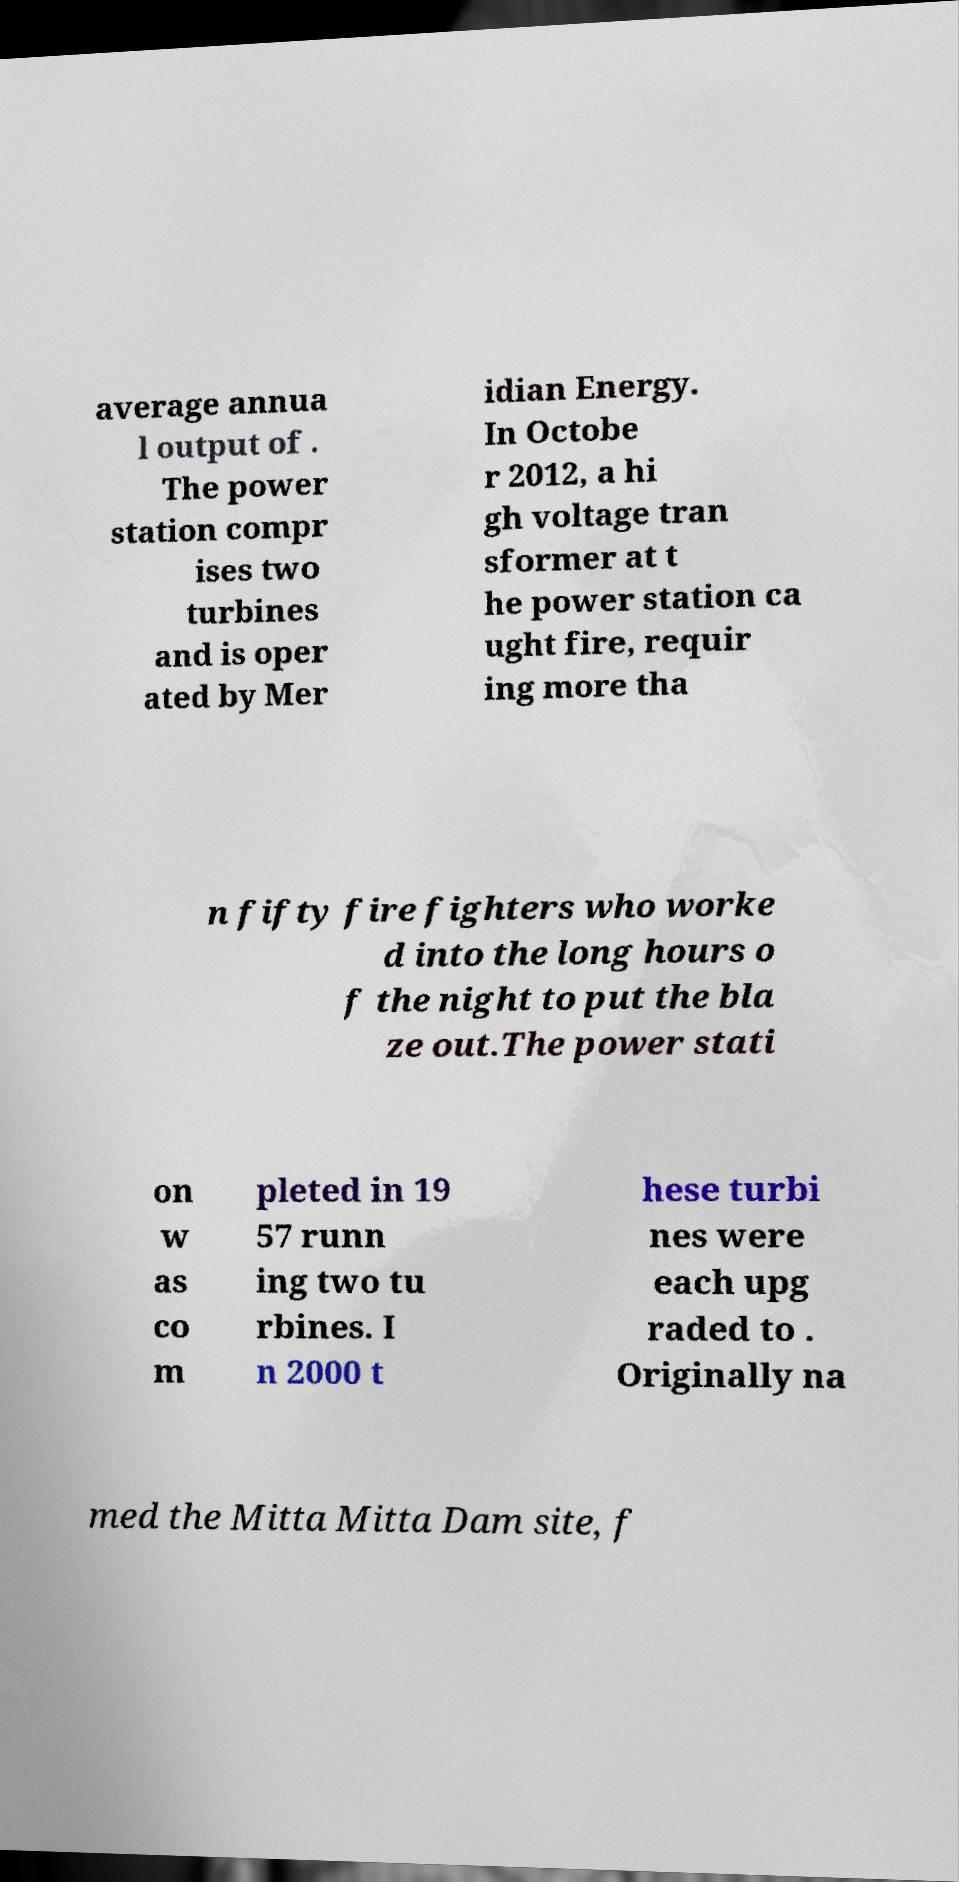Please read and relay the text visible in this image. What does it say? average annua l output of . The power station compr ises two turbines and is oper ated by Mer idian Energy. In Octobe r 2012, a hi gh voltage tran sformer at t he power station ca ught fire, requir ing more tha n fifty fire fighters who worke d into the long hours o f the night to put the bla ze out.The power stati on w as co m pleted in 19 57 runn ing two tu rbines. I n 2000 t hese turbi nes were each upg raded to . Originally na med the Mitta Mitta Dam site, f 